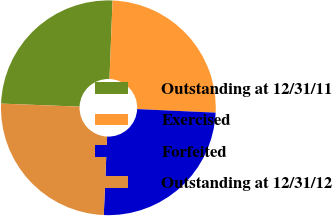<chart> <loc_0><loc_0><loc_500><loc_500><pie_chart><fcel>Outstanding at 12/31/11<fcel>Exercised<fcel>Forfeited<fcel>Outstanding at 12/31/12<nl><fcel>25.0%<fcel>25.1%<fcel>24.96%<fcel>24.94%<nl></chart> 